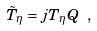<formula> <loc_0><loc_0><loc_500><loc_500>\tilde { T } _ { \eta } = j T _ { \eta } Q \ ,</formula> 